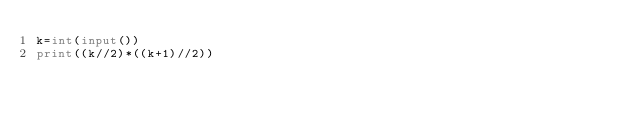Convert code to text. <code><loc_0><loc_0><loc_500><loc_500><_Python_>k=int(input())
print((k//2)*((k+1)//2))</code> 